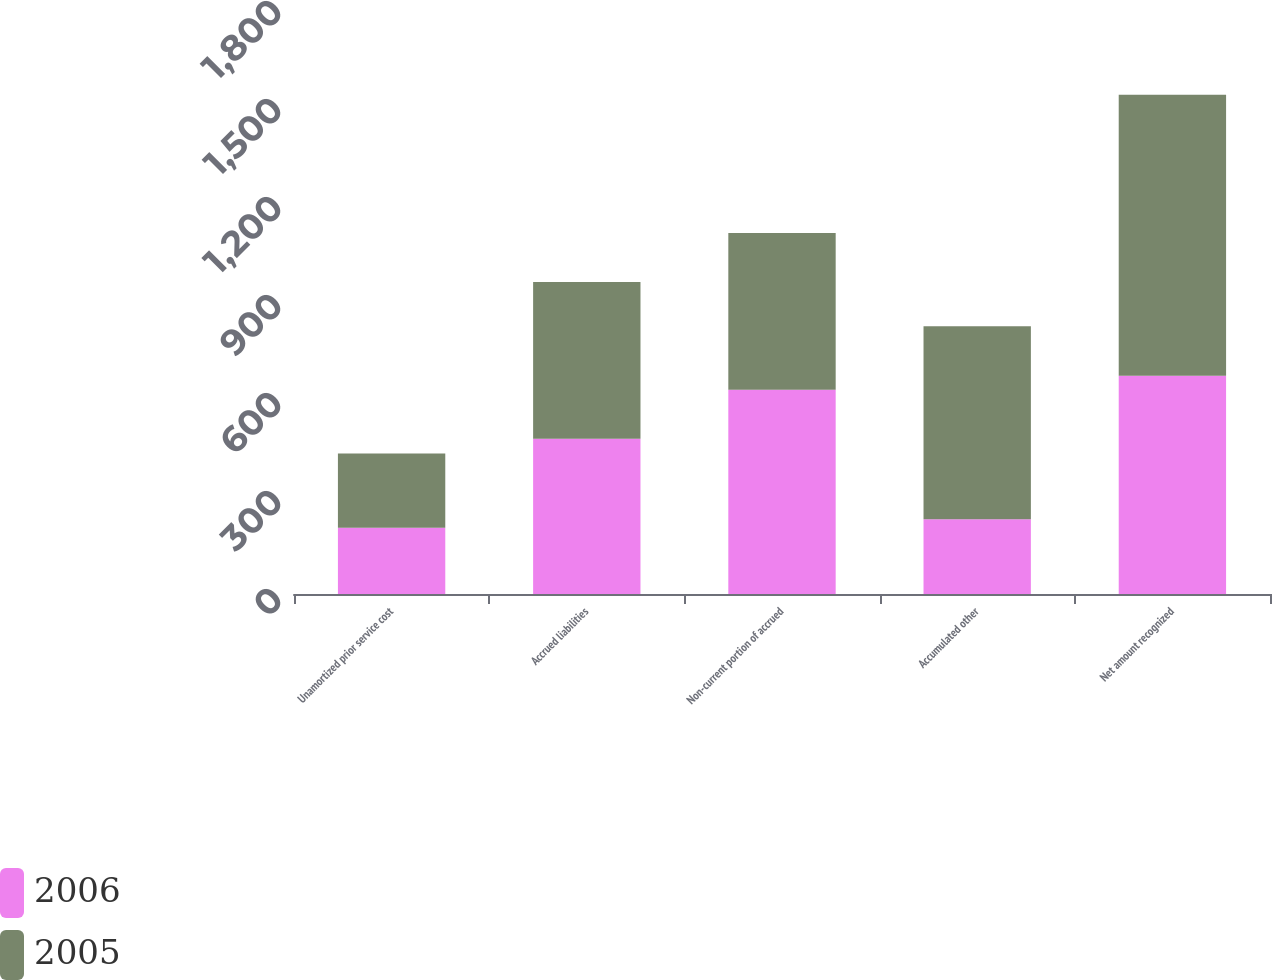Convert chart. <chart><loc_0><loc_0><loc_500><loc_500><stacked_bar_chart><ecel><fcel>Unamortized prior service cost<fcel>Accrued liabilities<fcel>Non-current portion of accrued<fcel>Accumulated other<fcel>Net amount recognized<nl><fcel>2006<fcel>203<fcel>475<fcel>625<fcel>229<fcel>668<nl><fcel>2005<fcel>227<fcel>480<fcel>480<fcel>591<fcel>860<nl></chart> 